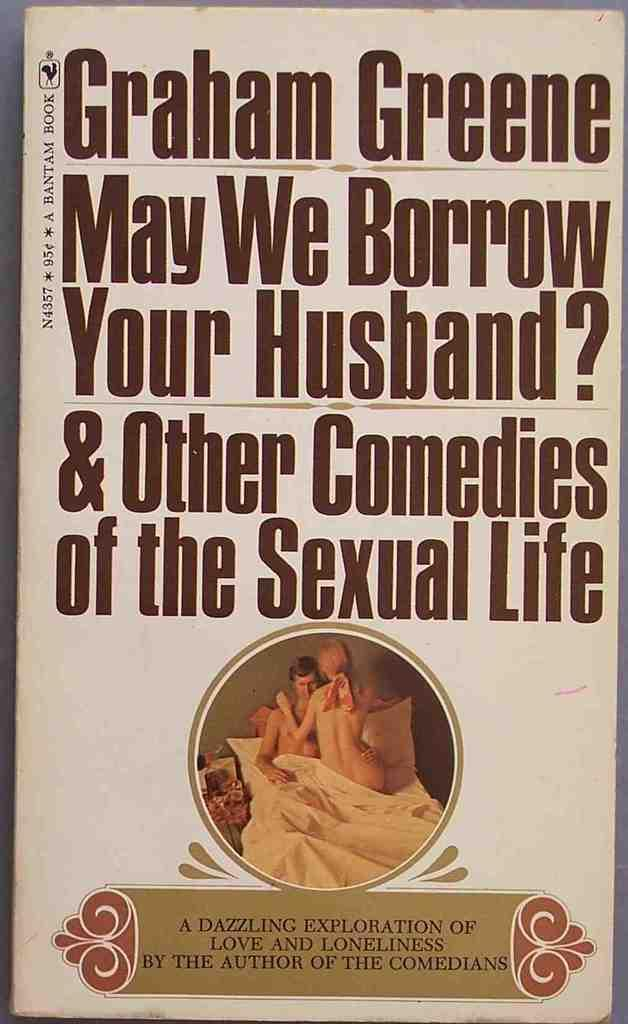What object can be seen in the image that contains text? There is a book in the image that contains text. What are the man and woman in the image doing? The man and woman are on a bed in the image. Can you describe the text visible in the image? There is text visible on the book in the image. What type of note is the man holding in the image? There is no note present in the image; the man and woman are on a bed, and there is a book with text visible. 